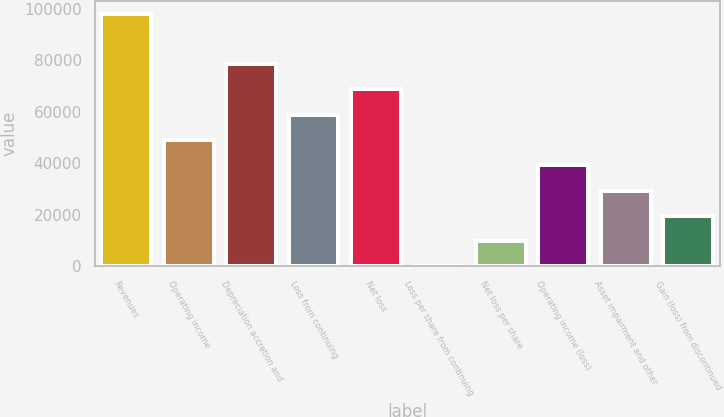Convert chart to OTSL. <chart><loc_0><loc_0><loc_500><loc_500><bar_chart><fcel>Revenues<fcel>Operating income<fcel>Depreciation accretion and<fcel>Loss from continuing<fcel>Net loss<fcel>Loss per share from continuing<fcel>Net loss per share<fcel>Operating income (loss)<fcel>Asset impairment and other<fcel>Gain (loss) from discontinued<nl><fcel>98172<fcel>49086.1<fcel>78537.7<fcel>58903.3<fcel>68720.5<fcel>0.23<fcel>9817.41<fcel>39268.9<fcel>29451.8<fcel>19634.6<nl></chart> 